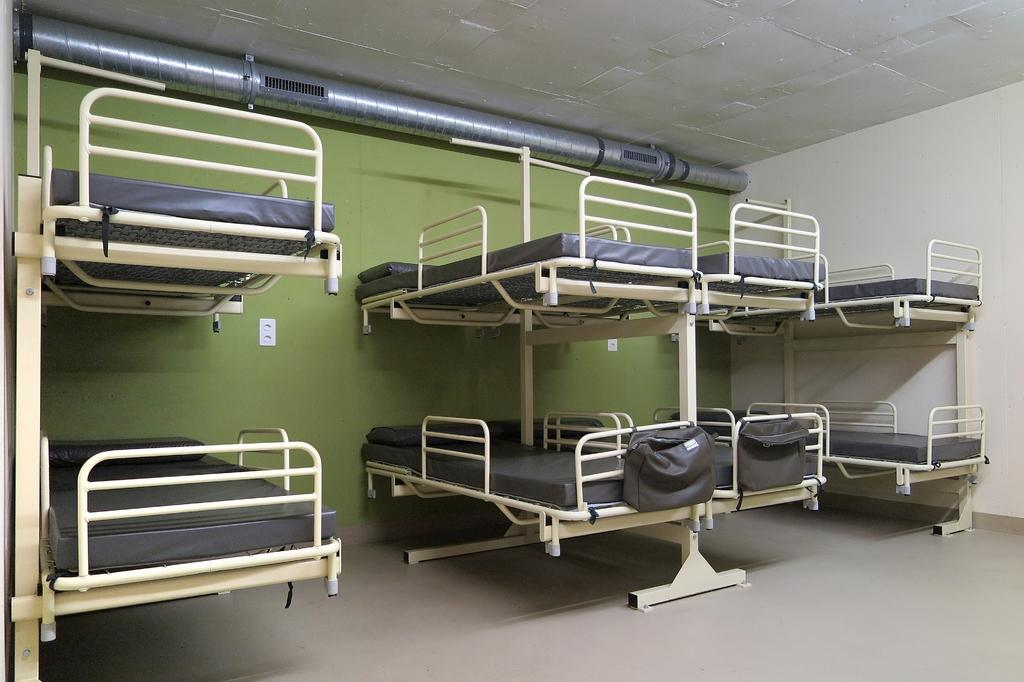What type of beds are in the image? There are bunk beds in the image. What items are near the beds? There are two bags near the beds. Can you describe the background of the image? There is a pope in the background of the image, and the wall is green. What type of wrist accessory is the pope wearing in the image? There is no wrist accessory visible on the pope in the image. Is there a volcano erupting in the background of the image? No, there is no volcano present in the image. 